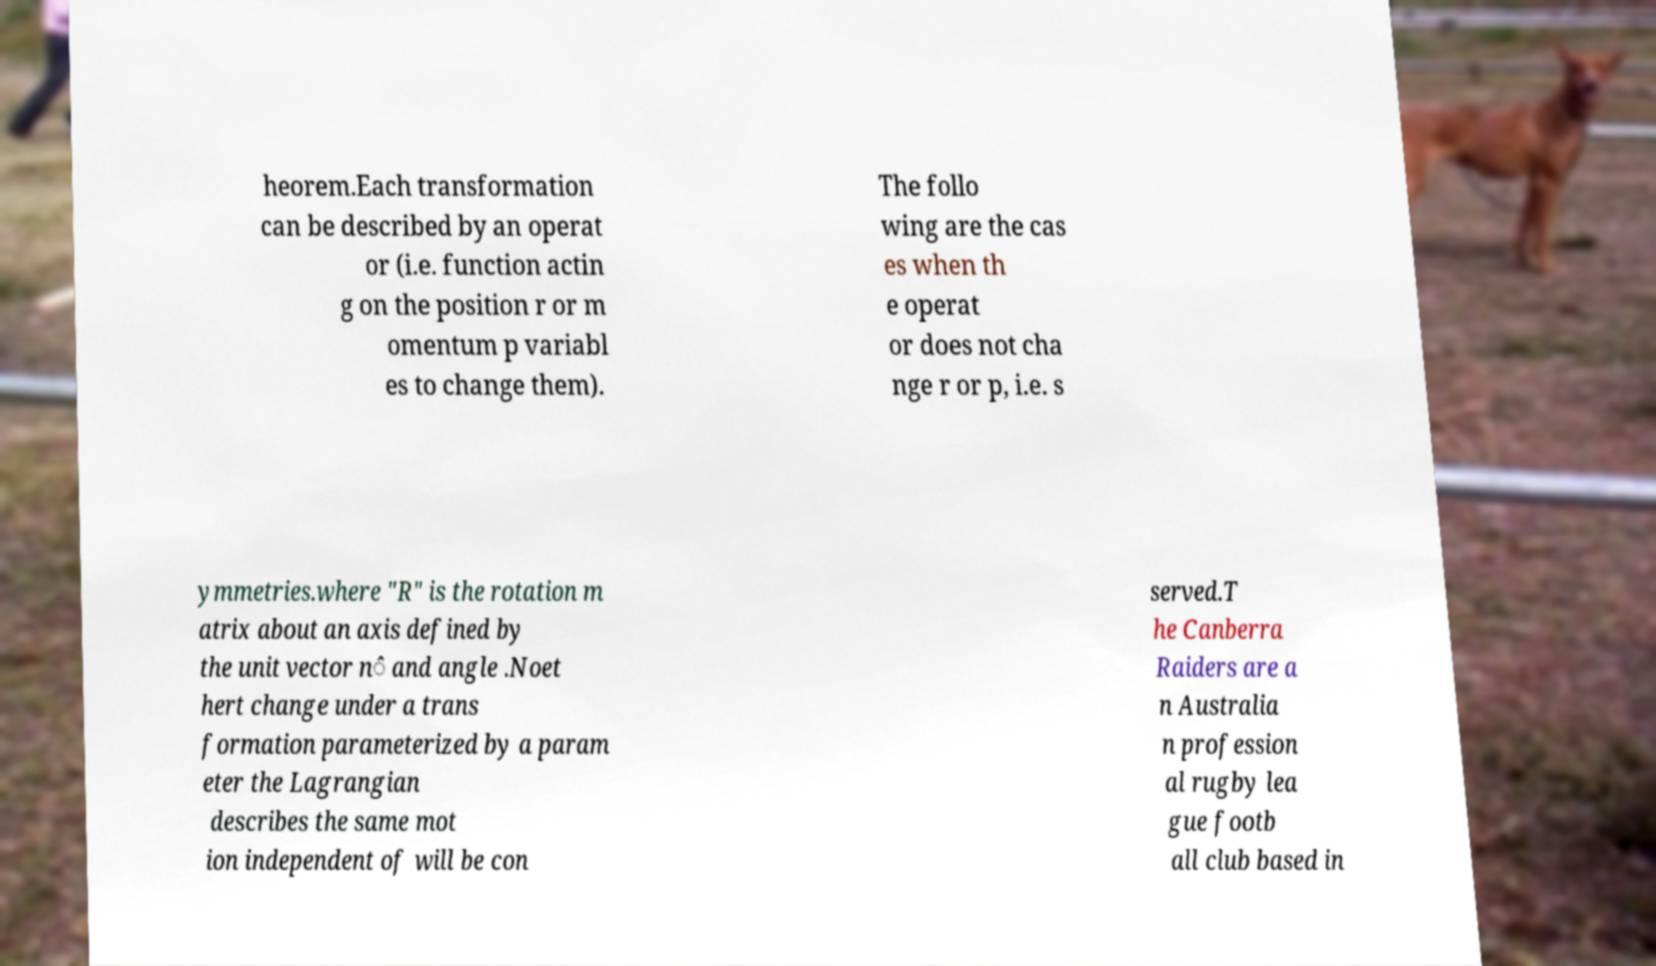I need the written content from this picture converted into text. Can you do that? heorem.Each transformation can be described by an operat or (i.e. function actin g on the position r or m omentum p variabl es to change them). The follo wing are the cas es when th e operat or does not cha nge r or p, i.e. s ymmetries.where "R" is the rotation m atrix about an axis defined by the unit vector n̂ and angle .Noet hert change under a trans formation parameterized by a param eter the Lagrangian describes the same mot ion independent of will be con served.T he Canberra Raiders are a n Australia n profession al rugby lea gue footb all club based in 